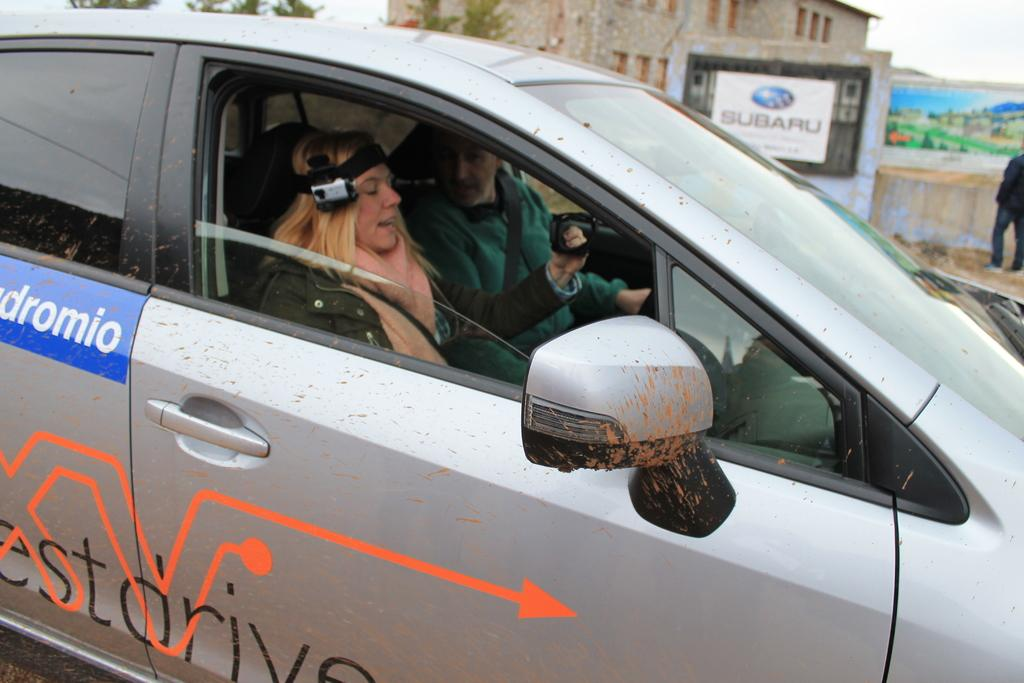How many people are inside the vehicle in the image? There are two persons sitting in the vehicle. What can be seen in the background of the image? There is a building visible in the background. Are there any other people present in the image besides the ones in the vehicle? Yes, there is a person standing in the background. What type of leather is used to make the vessel in the image? There is no vessel or leather present in the image. How many rings can be seen on the person standing in the background? There is no person wearing rings in the image; only one person is standing in the background. 